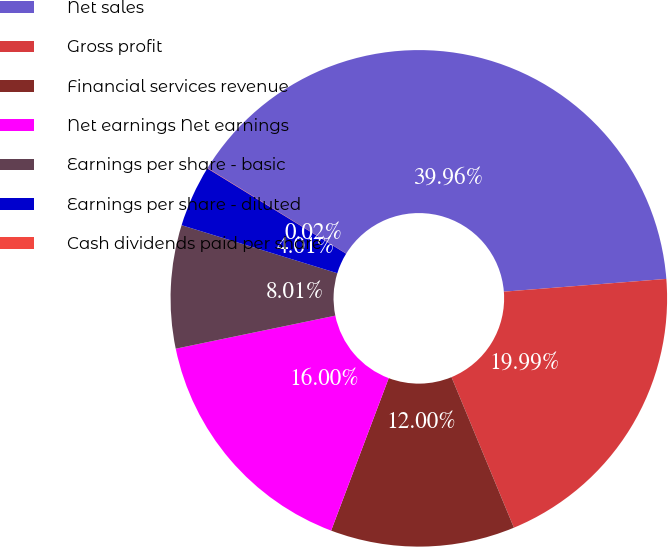Convert chart. <chart><loc_0><loc_0><loc_500><loc_500><pie_chart><fcel>Net sales<fcel>Gross profit<fcel>Financial services revenue<fcel>Net earnings Net earnings<fcel>Earnings per share - basic<fcel>Earnings per share - diluted<fcel>Cash dividends paid per share<nl><fcel>39.96%<fcel>19.99%<fcel>12.0%<fcel>16.0%<fcel>8.01%<fcel>4.01%<fcel>0.02%<nl></chart> 